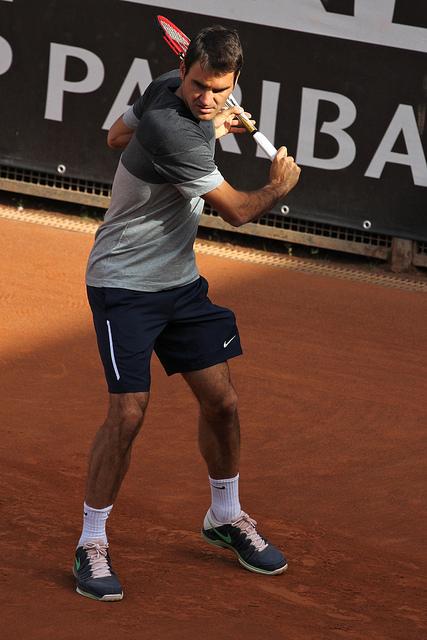Is the man wearing wristband?
Be succinct. No. What color are his tennis shoes?
Answer briefly. Blue. What is bulging from his pocket?
Give a very brief answer. Ball. What sport is the man playing?
Write a very short answer. Tennis. What color is the player's shorts?
Quick response, please. Black. 